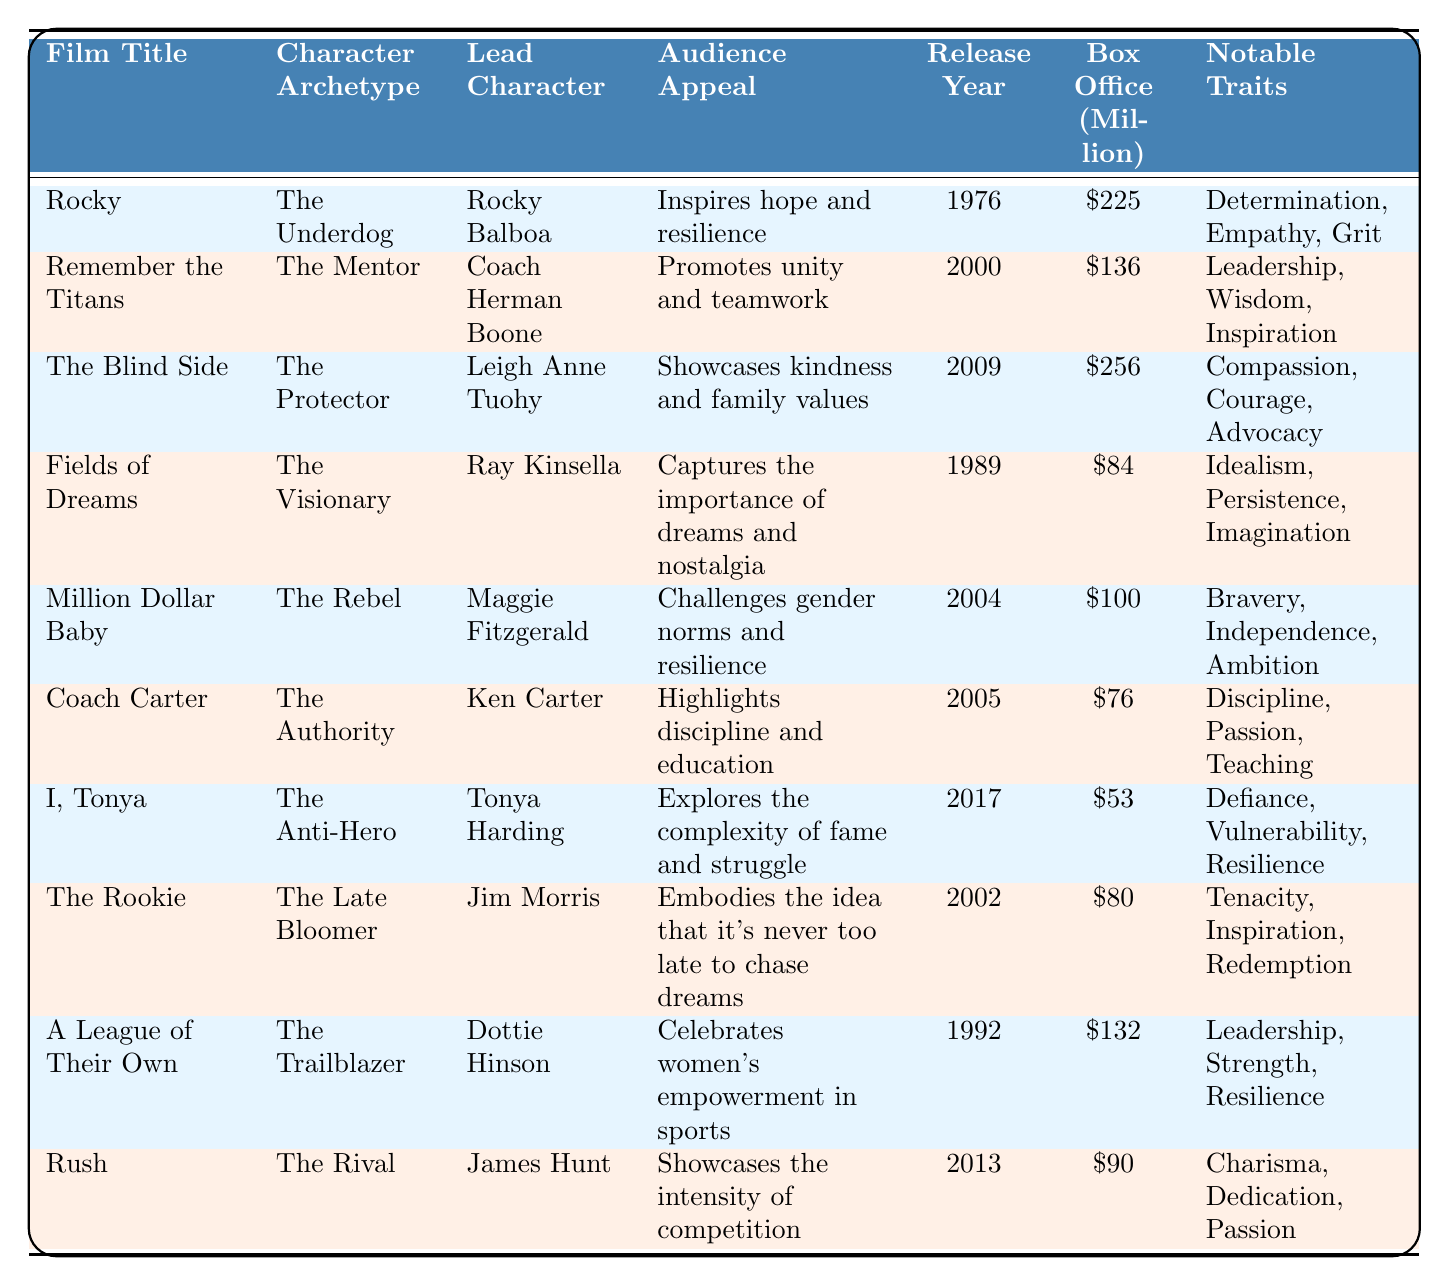What is the lead character of "Rocky"? The table lists "Rocky Balboa" as the lead character for the film "Rocky."
Answer: Rocky Balboa Which film features "Coach Herman Boone" as the lead character? According to the table, "Remember the Titans" features "Coach Herman Boone" as the lead character.
Answer: Remember the Titans What is the box office gross of "A League of Their Own"? The table states that the box office gross of "A League of Their Own" is 132 million.
Answer: 132 million Which character archetype is associated with "Maggie Fitzgerald"? The table indicates that "Maggie Fitzgerald" is associated with the archetype "The Rebel."
Answer: The Rebel What year was "The Blind Side" released? The release year for "The Blind Side" is given in the table as 2009.
Answer: 2009 Which film has the highest box office gross? To find the highest box office gross, we compare the values: "Rocky" (225 million), "Remember the Titans" (136 million), "The Blind Side" (256 million), "Fields of Dreams" (84 million), "Million Dollar Baby" (100 million), "Coach Carter" (76 million), "I, Tonya" (53 million), "The Rookie" (80 million), "A League of Their Own" (132 million), and "Rush" (90 million). The highest among these is "The Blind Side" with 256 million.
Answer: The Blind Side What notable trait is common between "Dottie Hinson" and "Coach Herman Boone"? The table shows that "Dottie Hinson" has notable traits such as Leadership, Strength, and Resilience, and "Coach Herman Boone" has traits of Leadership, Wisdom, and Inspiration. Both have "Leadership" as a common notable trait.
Answer: Leadership Is it true that "I, Tonya" showcases kindness and family values? The audience appeal for "I, Tonya" is "Explores the complexity of fame and struggle," which does not mention kindness or family values, indicating that it is false.
Answer: No What character archetype appears most frequently among the films listed? By reviewing the character archetypes: "The Underdog" (1), "The Mentor" (1), "The Protector" (1), "The Visionary" (1), "The Rebel" (1), "The Authority" (1), "The Anti-Hero" (1), "The Late Bloomer" (1), "The Trailblazer" (1), and "The Rival" (1), we see each appears only once. Therefore, no archetype appears more frequently than others.
Answer: None Which film's audience appeal relates to the importance of dreams? The table shows that "Fields of Dreams" has an audience appeal that captures the importance of dreams and nostalgia.
Answer: Fields of Dreams Calculate the average box office gross of the films released before 2000. The films released before 2000 are "Rocky" (225), "Fields of Dreams" (84), "A League of Their Own" (132), and the total gross is 225 + 84 + 132 = 441 million. There are 3 films, so the average is 441/3 = 147 million.
Answer: 147 million 